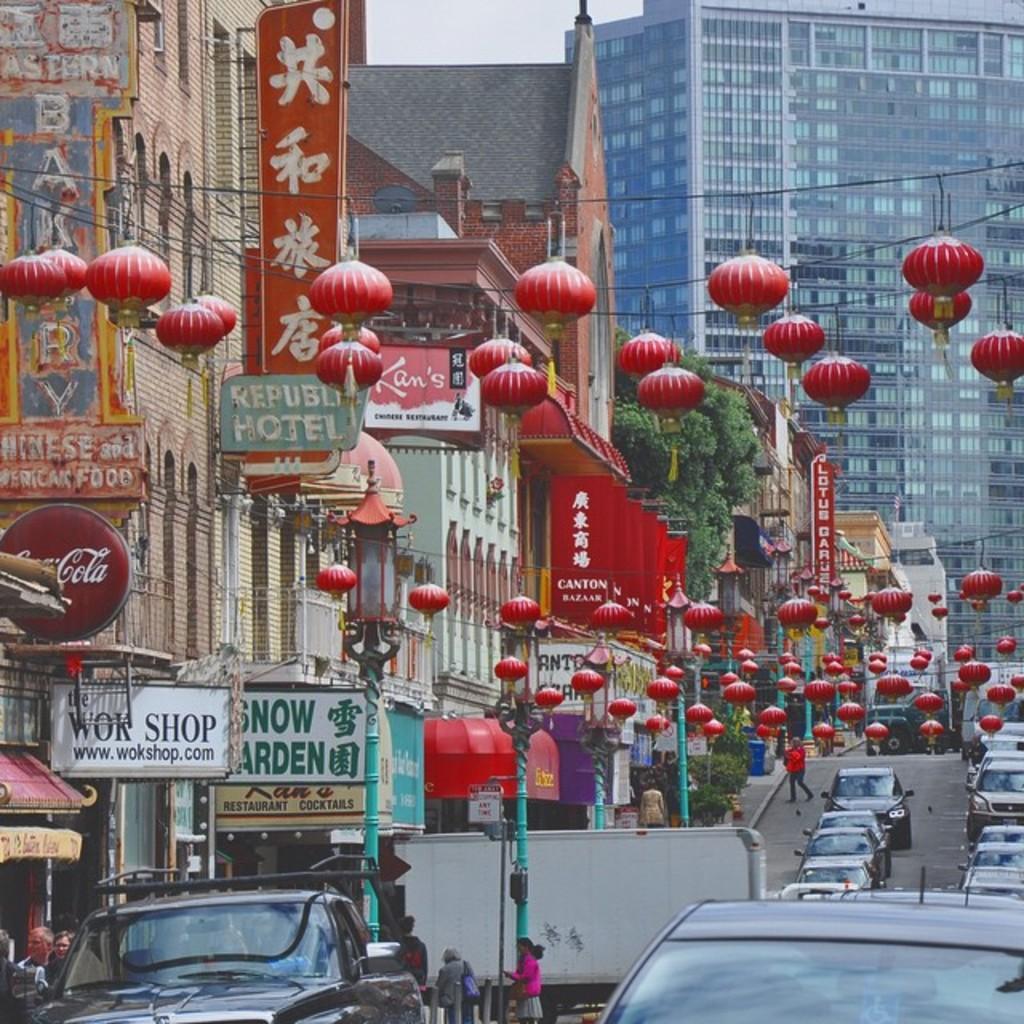Can you describe this image briefly? On the right side there is a road. On the road there are many vehicles. There are few people. There are poles with lights. On the left side there are many buildings. Also there are name boards. Also there are some decorative items hanged. 